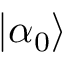<formula> <loc_0><loc_0><loc_500><loc_500>\left | \alpha _ { 0 } \right \rangle</formula> 